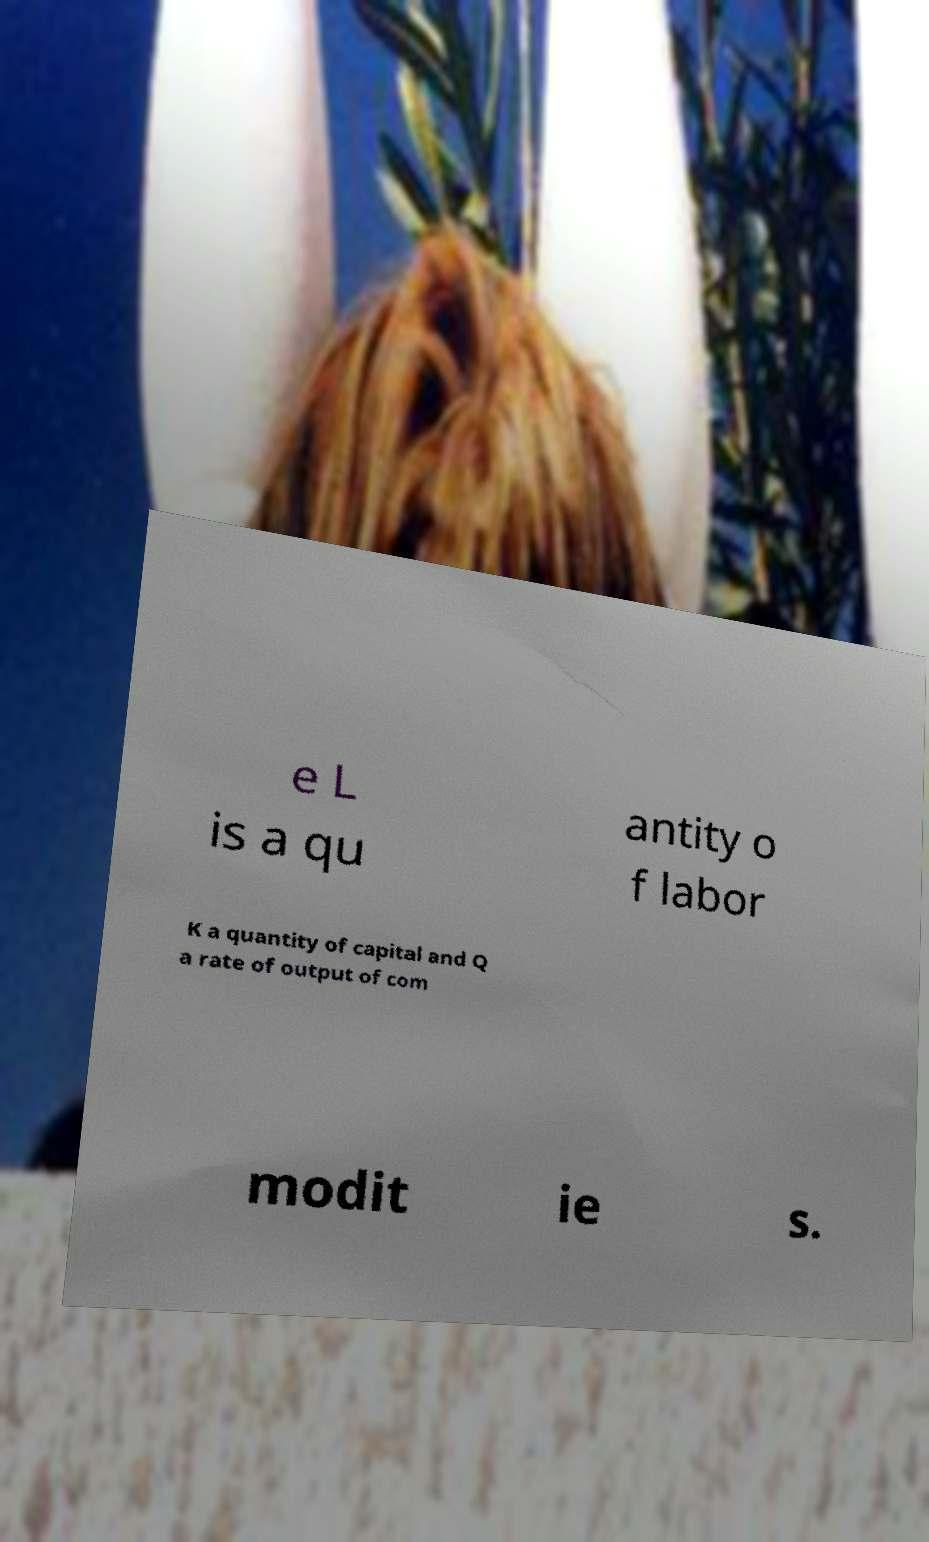There's text embedded in this image that I need extracted. Can you transcribe it verbatim? e L is a qu antity o f labor K a quantity of capital and Q a rate of output of com modit ie s. 